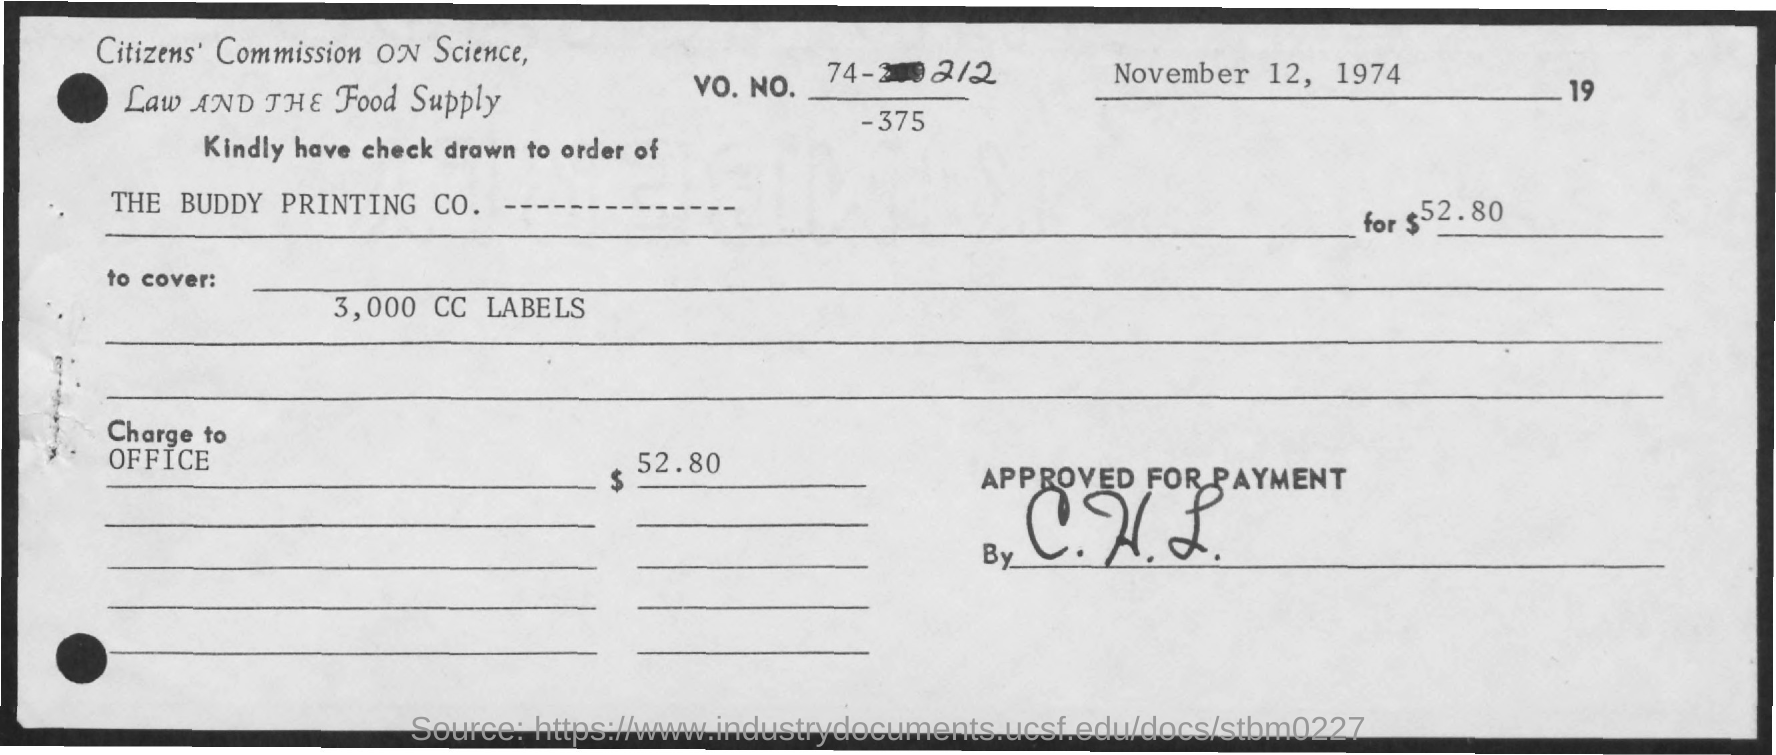What is the date on the document?
Provide a short and direct response. November 12, 1974. What is the VO. NO.?
Provide a succinct answer. 74-212. Check is drawn to the order of?
Offer a very short reply. The buddy printing co. What is the Amount?
Your response must be concise. $52.80. The amount is to cover?
Provide a succinct answer. 3,000 cc labels. What is the "charge to"?
Offer a terse response. Office. 